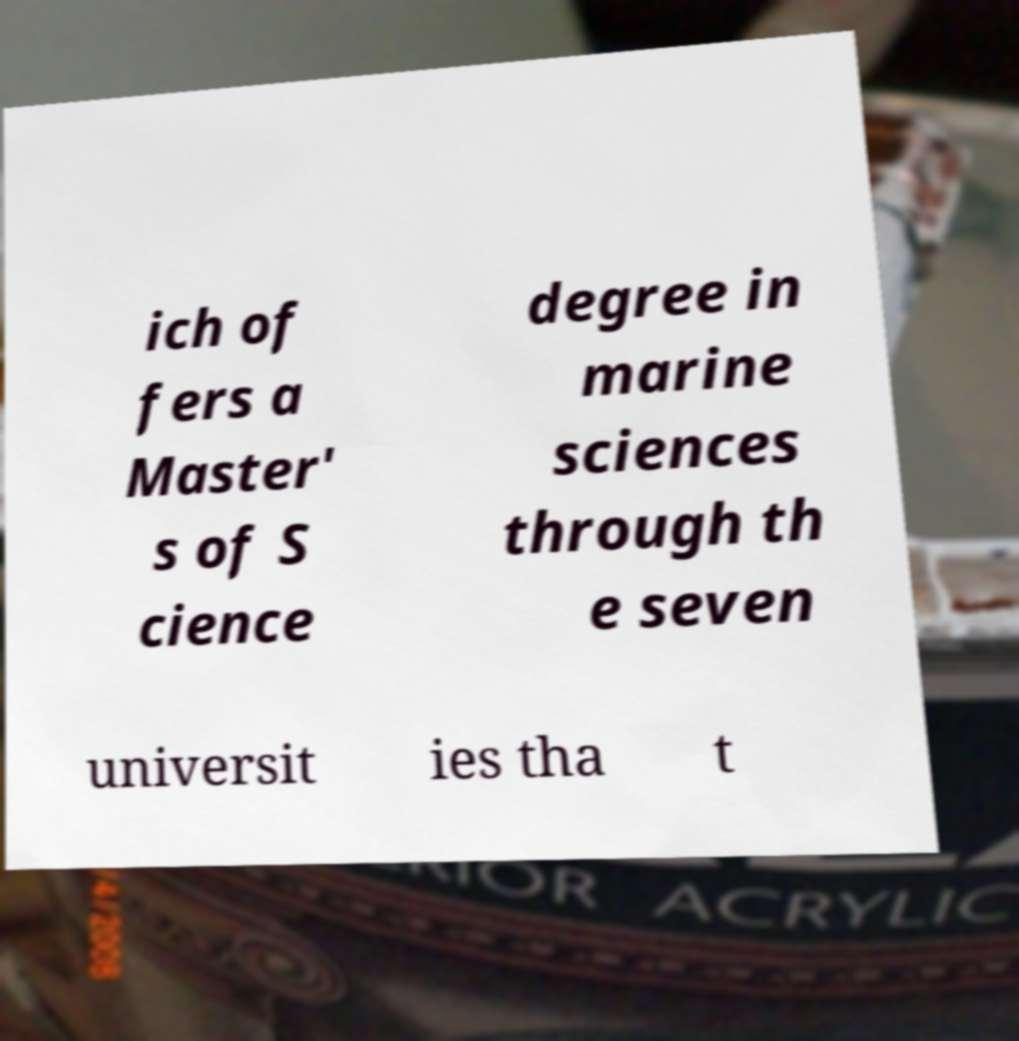What messages or text are displayed in this image? I need them in a readable, typed format. ich of fers a Master' s of S cience degree in marine sciences through th e seven universit ies tha t 